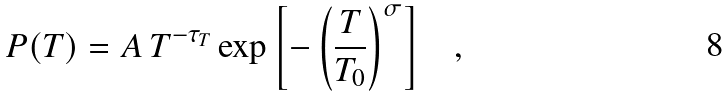Convert formula to latex. <formula><loc_0><loc_0><loc_500><loc_500>P ( T ) = A \, T ^ { - \tau _ { T } } \exp { \left [ - \left ( \frac { T } { T _ { 0 } } \right ) ^ { \sigma } \right ] } \quad ,</formula> 